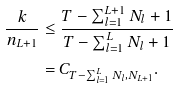<formula> <loc_0><loc_0><loc_500><loc_500>\frac { k } { n _ { L + 1 } } & \leq \frac { T - \sum _ { l = 1 } ^ { L + 1 } N _ { l } + 1 } { T - \sum _ { l = 1 } ^ { L } N _ { l } + 1 } \\ & = C _ { T - \sum _ { l = 1 } ^ { L } N _ { l } , N _ { L + 1 } } .</formula> 